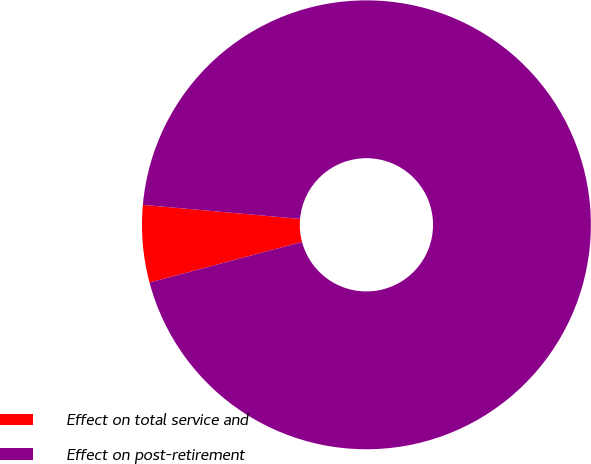<chart> <loc_0><loc_0><loc_500><loc_500><pie_chart><fcel>Effect on total service and<fcel>Effect on post-retirement<nl><fcel>5.56%<fcel>94.44%<nl></chart> 